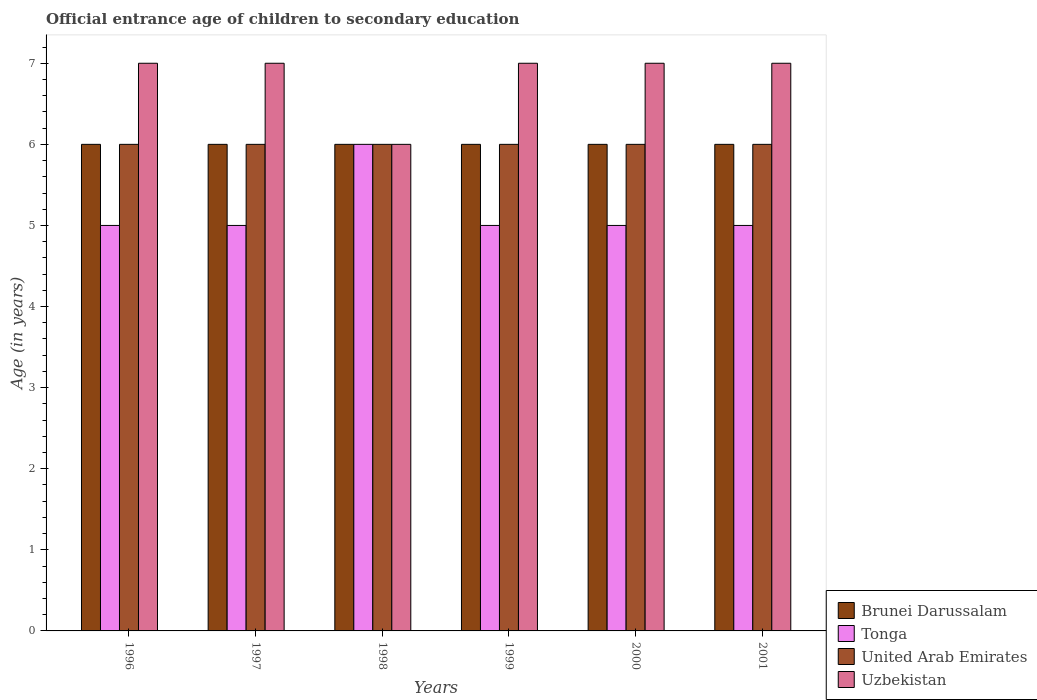How many different coloured bars are there?
Keep it short and to the point. 4. How many bars are there on the 2nd tick from the left?
Give a very brief answer. 4. In how many cases, is the number of bars for a given year not equal to the number of legend labels?
Offer a very short reply. 0. What is the secondary school starting age of children in Uzbekistan in 2001?
Keep it short and to the point. 7. In which year was the secondary school starting age of children in United Arab Emirates minimum?
Your answer should be very brief. 1996. What is the total secondary school starting age of children in Uzbekistan in the graph?
Your response must be concise. 41. What is the difference between the secondary school starting age of children in Tonga in 1998 and that in 2001?
Your answer should be very brief. 1. What is the difference between the secondary school starting age of children in Tonga in 1996 and the secondary school starting age of children in Uzbekistan in 1999?
Keep it short and to the point. -2. In how many years, is the secondary school starting age of children in Uzbekistan greater than 1.2 years?
Your answer should be compact. 6. What is the difference between the highest and the second highest secondary school starting age of children in Brunei Darussalam?
Provide a short and direct response. 0. What is the difference between the highest and the lowest secondary school starting age of children in United Arab Emirates?
Offer a terse response. 0. In how many years, is the secondary school starting age of children in Uzbekistan greater than the average secondary school starting age of children in Uzbekistan taken over all years?
Provide a succinct answer. 5. Is the sum of the secondary school starting age of children in Brunei Darussalam in 1998 and 2001 greater than the maximum secondary school starting age of children in United Arab Emirates across all years?
Make the answer very short. Yes. Is it the case that in every year, the sum of the secondary school starting age of children in Brunei Darussalam and secondary school starting age of children in United Arab Emirates is greater than the sum of secondary school starting age of children in Uzbekistan and secondary school starting age of children in Tonga?
Your answer should be compact. No. What does the 3rd bar from the left in 1996 represents?
Offer a terse response. United Arab Emirates. What does the 3rd bar from the right in 1998 represents?
Provide a succinct answer. Tonga. How many bars are there?
Your answer should be compact. 24. Does the graph contain any zero values?
Make the answer very short. No. Does the graph contain grids?
Offer a terse response. No. Where does the legend appear in the graph?
Make the answer very short. Bottom right. How many legend labels are there?
Your response must be concise. 4. What is the title of the graph?
Offer a very short reply. Official entrance age of children to secondary education. What is the label or title of the Y-axis?
Make the answer very short. Age (in years). What is the Age (in years) of Brunei Darussalam in 1996?
Offer a very short reply. 6. What is the Age (in years) of Tonga in 1996?
Offer a terse response. 5. What is the Age (in years) in Tonga in 1997?
Make the answer very short. 5. What is the Age (in years) of United Arab Emirates in 1997?
Offer a terse response. 6. What is the Age (in years) in Tonga in 1998?
Offer a very short reply. 6. What is the Age (in years) in Uzbekistan in 1998?
Provide a short and direct response. 6. What is the Age (in years) of Uzbekistan in 1999?
Make the answer very short. 7. What is the Age (in years) in Brunei Darussalam in 2000?
Give a very brief answer. 6. What is the Age (in years) of Uzbekistan in 2000?
Ensure brevity in your answer.  7. What is the Age (in years) in Brunei Darussalam in 2001?
Make the answer very short. 6. Across all years, what is the maximum Age (in years) in Tonga?
Provide a short and direct response. 6. Across all years, what is the maximum Age (in years) in United Arab Emirates?
Your answer should be very brief. 6. Across all years, what is the maximum Age (in years) of Uzbekistan?
Your answer should be compact. 7. Across all years, what is the minimum Age (in years) in Brunei Darussalam?
Provide a succinct answer. 6. Across all years, what is the minimum Age (in years) of Tonga?
Offer a terse response. 5. Across all years, what is the minimum Age (in years) in United Arab Emirates?
Your answer should be compact. 6. Across all years, what is the minimum Age (in years) in Uzbekistan?
Give a very brief answer. 6. What is the difference between the Age (in years) in United Arab Emirates in 1996 and that in 1997?
Offer a very short reply. 0. What is the difference between the Age (in years) in Tonga in 1996 and that in 1998?
Make the answer very short. -1. What is the difference between the Age (in years) in United Arab Emirates in 1996 and that in 1998?
Give a very brief answer. 0. What is the difference between the Age (in years) of Uzbekistan in 1996 and that in 1998?
Offer a terse response. 1. What is the difference between the Age (in years) in United Arab Emirates in 1996 and that in 1999?
Your answer should be compact. 0. What is the difference between the Age (in years) in Brunei Darussalam in 1996 and that in 2000?
Ensure brevity in your answer.  0. What is the difference between the Age (in years) of United Arab Emirates in 1996 and that in 2000?
Your answer should be very brief. 0. What is the difference between the Age (in years) of Uzbekistan in 1996 and that in 2000?
Your answer should be very brief. 0. What is the difference between the Age (in years) of Tonga in 1996 and that in 2001?
Give a very brief answer. 0. What is the difference between the Age (in years) in Uzbekistan in 1996 and that in 2001?
Your answer should be very brief. 0. What is the difference between the Age (in years) in Brunei Darussalam in 1997 and that in 1998?
Keep it short and to the point. 0. What is the difference between the Age (in years) of Tonga in 1997 and that in 1998?
Keep it short and to the point. -1. What is the difference between the Age (in years) in Brunei Darussalam in 1997 and that in 1999?
Give a very brief answer. 0. What is the difference between the Age (in years) of United Arab Emirates in 1997 and that in 1999?
Provide a succinct answer. 0. What is the difference between the Age (in years) of Uzbekistan in 1997 and that in 1999?
Offer a terse response. 0. What is the difference between the Age (in years) of United Arab Emirates in 1997 and that in 2000?
Offer a terse response. 0. What is the difference between the Age (in years) in Uzbekistan in 1997 and that in 2000?
Make the answer very short. 0. What is the difference between the Age (in years) of Brunei Darussalam in 1997 and that in 2001?
Your answer should be compact. 0. What is the difference between the Age (in years) of Tonga in 1997 and that in 2001?
Your answer should be compact. 0. What is the difference between the Age (in years) in United Arab Emirates in 1997 and that in 2001?
Your response must be concise. 0. What is the difference between the Age (in years) of Uzbekistan in 1997 and that in 2001?
Make the answer very short. 0. What is the difference between the Age (in years) in Tonga in 1998 and that in 1999?
Provide a succinct answer. 1. What is the difference between the Age (in years) in United Arab Emirates in 1998 and that in 1999?
Provide a succinct answer. 0. What is the difference between the Age (in years) in Uzbekistan in 1998 and that in 1999?
Make the answer very short. -1. What is the difference between the Age (in years) of Brunei Darussalam in 1998 and that in 2000?
Keep it short and to the point. 0. What is the difference between the Age (in years) of Tonga in 1998 and that in 2000?
Ensure brevity in your answer.  1. What is the difference between the Age (in years) in United Arab Emirates in 1998 and that in 2000?
Offer a terse response. 0. What is the difference between the Age (in years) in Uzbekistan in 1998 and that in 2000?
Give a very brief answer. -1. What is the difference between the Age (in years) in Tonga in 1998 and that in 2001?
Offer a very short reply. 1. What is the difference between the Age (in years) of United Arab Emirates in 1998 and that in 2001?
Your response must be concise. 0. What is the difference between the Age (in years) of Tonga in 1999 and that in 2000?
Ensure brevity in your answer.  0. What is the difference between the Age (in years) of Tonga in 1999 and that in 2001?
Keep it short and to the point. 0. What is the difference between the Age (in years) of United Arab Emirates in 1999 and that in 2001?
Keep it short and to the point. 0. What is the difference between the Age (in years) of Brunei Darussalam in 2000 and that in 2001?
Provide a short and direct response. 0. What is the difference between the Age (in years) of Brunei Darussalam in 1996 and the Age (in years) of United Arab Emirates in 1997?
Give a very brief answer. 0. What is the difference between the Age (in years) of Tonga in 1996 and the Age (in years) of United Arab Emirates in 1997?
Offer a very short reply. -1. What is the difference between the Age (in years) in Brunei Darussalam in 1996 and the Age (in years) in Tonga in 1998?
Your response must be concise. 0. What is the difference between the Age (in years) in Brunei Darussalam in 1996 and the Age (in years) in United Arab Emirates in 1998?
Offer a very short reply. 0. What is the difference between the Age (in years) of Brunei Darussalam in 1996 and the Age (in years) of Uzbekistan in 1998?
Make the answer very short. 0. What is the difference between the Age (in years) of Tonga in 1996 and the Age (in years) of United Arab Emirates in 1998?
Ensure brevity in your answer.  -1. What is the difference between the Age (in years) of Tonga in 1996 and the Age (in years) of Uzbekistan in 1999?
Keep it short and to the point. -2. What is the difference between the Age (in years) of United Arab Emirates in 1996 and the Age (in years) of Uzbekistan in 1999?
Make the answer very short. -1. What is the difference between the Age (in years) of Brunei Darussalam in 1996 and the Age (in years) of Uzbekistan in 2000?
Ensure brevity in your answer.  -1. What is the difference between the Age (in years) of Tonga in 1996 and the Age (in years) of United Arab Emirates in 2000?
Your response must be concise. -1. What is the difference between the Age (in years) in Brunei Darussalam in 1996 and the Age (in years) in United Arab Emirates in 2001?
Offer a terse response. 0. What is the difference between the Age (in years) of Brunei Darussalam in 1996 and the Age (in years) of Uzbekistan in 2001?
Offer a very short reply. -1. What is the difference between the Age (in years) in Tonga in 1996 and the Age (in years) in United Arab Emirates in 2001?
Provide a short and direct response. -1. What is the difference between the Age (in years) of United Arab Emirates in 1996 and the Age (in years) of Uzbekistan in 2001?
Keep it short and to the point. -1. What is the difference between the Age (in years) in Brunei Darussalam in 1997 and the Age (in years) in Uzbekistan in 1998?
Provide a succinct answer. 0. What is the difference between the Age (in years) in Tonga in 1997 and the Age (in years) in United Arab Emirates in 1998?
Offer a very short reply. -1. What is the difference between the Age (in years) of Brunei Darussalam in 1997 and the Age (in years) of Tonga in 1999?
Your answer should be compact. 1. What is the difference between the Age (in years) in Tonga in 1997 and the Age (in years) in United Arab Emirates in 1999?
Your answer should be very brief. -1. What is the difference between the Age (in years) in Brunei Darussalam in 1997 and the Age (in years) in Uzbekistan in 2000?
Provide a succinct answer. -1. What is the difference between the Age (in years) in Tonga in 1997 and the Age (in years) in United Arab Emirates in 2000?
Give a very brief answer. -1. What is the difference between the Age (in years) of United Arab Emirates in 1997 and the Age (in years) of Uzbekistan in 2000?
Your response must be concise. -1. What is the difference between the Age (in years) of Brunei Darussalam in 1997 and the Age (in years) of Tonga in 2001?
Keep it short and to the point. 1. What is the difference between the Age (in years) in Brunei Darussalam in 1997 and the Age (in years) in United Arab Emirates in 2001?
Your answer should be very brief. 0. What is the difference between the Age (in years) in Tonga in 1997 and the Age (in years) in Uzbekistan in 2001?
Make the answer very short. -2. What is the difference between the Age (in years) of Brunei Darussalam in 1998 and the Age (in years) of Tonga in 1999?
Provide a short and direct response. 1. What is the difference between the Age (in years) of Brunei Darussalam in 1998 and the Age (in years) of United Arab Emirates in 1999?
Give a very brief answer. 0. What is the difference between the Age (in years) of Tonga in 1998 and the Age (in years) of United Arab Emirates in 1999?
Provide a succinct answer. 0. What is the difference between the Age (in years) of United Arab Emirates in 1998 and the Age (in years) of Uzbekistan in 1999?
Provide a short and direct response. -1. What is the difference between the Age (in years) in Brunei Darussalam in 1998 and the Age (in years) in United Arab Emirates in 2000?
Offer a very short reply. 0. What is the difference between the Age (in years) in Tonga in 1998 and the Age (in years) in United Arab Emirates in 2000?
Offer a terse response. 0. What is the difference between the Age (in years) in United Arab Emirates in 1998 and the Age (in years) in Uzbekistan in 2000?
Ensure brevity in your answer.  -1. What is the difference between the Age (in years) in Brunei Darussalam in 1998 and the Age (in years) in Tonga in 2001?
Offer a terse response. 1. What is the difference between the Age (in years) of Brunei Darussalam in 1998 and the Age (in years) of United Arab Emirates in 2001?
Provide a short and direct response. 0. What is the difference between the Age (in years) of Tonga in 1998 and the Age (in years) of Uzbekistan in 2001?
Ensure brevity in your answer.  -1. What is the difference between the Age (in years) of United Arab Emirates in 1998 and the Age (in years) of Uzbekistan in 2001?
Ensure brevity in your answer.  -1. What is the difference between the Age (in years) in Brunei Darussalam in 1999 and the Age (in years) in Uzbekistan in 2000?
Keep it short and to the point. -1. What is the difference between the Age (in years) of Brunei Darussalam in 1999 and the Age (in years) of Tonga in 2001?
Offer a terse response. 1. What is the difference between the Age (in years) in Brunei Darussalam in 1999 and the Age (in years) in United Arab Emirates in 2001?
Make the answer very short. 0. What is the difference between the Age (in years) in Brunei Darussalam in 1999 and the Age (in years) in Uzbekistan in 2001?
Your answer should be very brief. -1. What is the difference between the Age (in years) of Tonga in 1999 and the Age (in years) of Uzbekistan in 2001?
Your answer should be compact. -2. What is the difference between the Age (in years) of United Arab Emirates in 1999 and the Age (in years) of Uzbekistan in 2001?
Ensure brevity in your answer.  -1. What is the difference between the Age (in years) of Brunei Darussalam in 2000 and the Age (in years) of Tonga in 2001?
Keep it short and to the point. 1. What is the difference between the Age (in years) of Brunei Darussalam in 2000 and the Age (in years) of Uzbekistan in 2001?
Your answer should be very brief. -1. What is the difference between the Age (in years) in United Arab Emirates in 2000 and the Age (in years) in Uzbekistan in 2001?
Your response must be concise. -1. What is the average Age (in years) in Tonga per year?
Make the answer very short. 5.17. What is the average Age (in years) of United Arab Emirates per year?
Offer a very short reply. 6. What is the average Age (in years) in Uzbekistan per year?
Offer a terse response. 6.83. In the year 1996, what is the difference between the Age (in years) in Tonga and Age (in years) in United Arab Emirates?
Ensure brevity in your answer.  -1. In the year 1996, what is the difference between the Age (in years) in Tonga and Age (in years) in Uzbekistan?
Offer a terse response. -2. In the year 1997, what is the difference between the Age (in years) in Brunei Darussalam and Age (in years) in Tonga?
Offer a very short reply. 1. In the year 1997, what is the difference between the Age (in years) in Brunei Darussalam and Age (in years) in United Arab Emirates?
Offer a very short reply. 0. In the year 1997, what is the difference between the Age (in years) of Tonga and Age (in years) of United Arab Emirates?
Your response must be concise. -1. In the year 1998, what is the difference between the Age (in years) in Brunei Darussalam and Age (in years) in United Arab Emirates?
Your response must be concise. 0. In the year 1998, what is the difference between the Age (in years) in United Arab Emirates and Age (in years) in Uzbekistan?
Offer a very short reply. 0. In the year 1999, what is the difference between the Age (in years) of Tonga and Age (in years) of United Arab Emirates?
Ensure brevity in your answer.  -1. In the year 2000, what is the difference between the Age (in years) in Brunei Darussalam and Age (in years) in Uzbekistan?
Offer a terse response. -1. In the year 2000, what is the difference between the Age (in years) of Tonga and Age (in years) of Uzbekistan?
Ensure brevity in your answer.  -2. In the year 2001, what is the difference between the Age (in years) of Brunei Darussalam and Age (in years) of Tonga?
Ensure brevity in your answer.  1. In the year 2001, what is the difference between the Age (in years) in Tonga and Age (in years) in United Arab Emirates?
Your response must be concise. -1. In the year 2001, what is the difference between the Age (in years) of Tonga and Age (in years) of Uzbekistan?
Your answer should be very brief. -2. What is the ratio of the Age (in years) in Brunei Darussalam in 1996 to that in 1997?
Provide a succinct answer. 1. What is the ratio of the Age (in years) of Tonga in 1996 to that in 1997?
Offer a terse response. 1. What is the ratio of the Age (in years) in Brunei Darussalam in 1996 to that in 1998?
Your answer should be compact. 1. What is the ratio of the Age (in years) of United Arab Emirates in 1996 to that in 1999?
Your response must be concise. 1. What is the ratio of the Age (in years) in Tonga in 1996 to that in 2001?
Give a very brief answer. 1. What is the ratio of the Age (in years) in Uzbekistan in 1996 to that in 2001?
Keep it short and to the point. 1. What is the ratio of the Age (in years) in Tonga in 1997 to that in 1998?
Provide a short and direct response. 0.83. What is the ratio of the Age (in years) of United Arab Emirates in 1997 to that in 1998?
Provide a short and direct response. 1. What is the ratio of the Age (in years) of Uzbekistan in 1997 to that in 1998?
Your answer should be very brief. 1.17. What is the ratio of the Age (in years) of Tonga in 1997 to that in 1999?
Make the answer very short. 1. What is the ratio of the Age (in years) of Brunei Darussalam in 1997 to that in 2000?
Offer a very short reply. 1. What is the ratio of the Age (in years) of United Arab Emirates in 1997 to that in 2000?
Offer a very short reply. 1. What is the ratio of the Age (in years) in United Arab Emirates in 1997 to that in 2001?
Your response must be concise. 1. What is the ratio of the Age (in years) of Uzbekistan in 1997 to that in 2001?
Your response must be concise. 1. What is the ratio of the Age (in years) of United Arab Emirates in 1998 to that in 1999?
Give a very brief answer. 1. What is the ratio of the Age (in years) in Uzbekistan in 1998 to that in 1999?
Offer a very short reply. 0.86. What is the ratio of the Age (in years) of United Arab Emirates in 1998 to that in 2000?
Give a very brief answer. 1. What is the ratio of the Age (in years) in Uzbekistan in 1998 to that in 2000?
Offer a terse response. 0.86. What is the ratio of the Age (in years) in Tonga in 1998 to that in 2001?
Your answer should be compact. 1.2. What is the ratio of the Age (in years) in Uzbekistan in 1998 to that in 2001?
Your response must be concise. 0.86. What is the ratio of the Age (in years) in United Arab Emirates in 1999 to that in 2000?
Keep it short and to the point. 1. What is the ratio of the Age (in years) of Uzbekistan in 1999 to that in 2001?
Keep it short and to the point. 1. What is the ratio of the Age (in years) in Brunei Darussalam in 2000 to that in 2001?
Offer a very short reply. 1. What is the ratio of the Age (in years) of United Arab Emirates in 2000 to that in 2001?
Keep it short and to the point. 1. What is the ratio of the Age (in years) in Uzbekistan in 2000 to that in 2001?
Make the answer very short. 1. What is the difference between the highest and the second highest Age (in years) in Brunei Darussalam?
Provide a short and direct response. 0. What is the difference between the highest and the second highest Age (in years) in United Arab Emirates?
Make the answer very short. 0. What is the difference between the highest and the lowest Age (in years) of Brunei Darussalam?
Make the answer very short. 0. What is the difference between the highest and the lowest Age (in years) in Tonga?
Your response must be concise. 1. What is the difference between the highest and the lowest Age (in years) in United Arab Emirates?
Your response must be concise. 0. What is the difference between the highest and the lowest Age (in years) of Uzbekistan?
Provide a succinct answer. 1. 